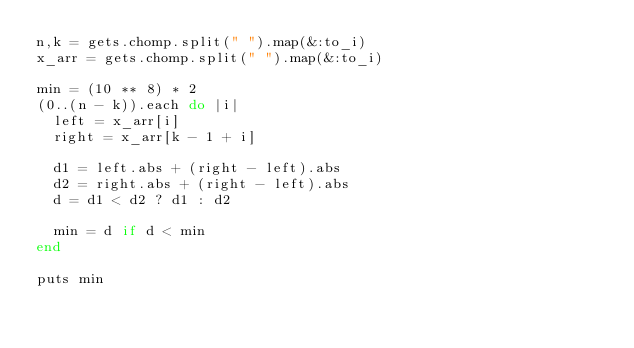Convert code to text. <code><loc_0><loc_0><loc_500><loc_500><_Ruby_>n,k = gets.chomp.split(" ").map(&:to_i)
x_arr = gets.chomp.split(" ").map(&:to_i)

min = (10 ** 8) * 2
(0..(n - k)).each do |i|
  left = x_arr[i]
  right = x_arr[k - 1 + i]

  d1 = left.abs + (right - left).abs
  d2 = right.abs + (right - left).abs
  d = d1 < d2 ? d1 : d2

  min = d if d < min
end

puts min
</code> 